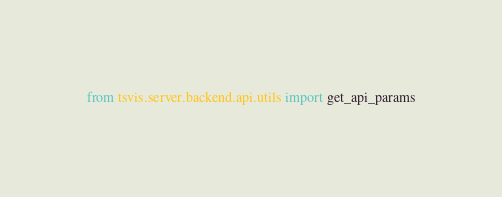Convert code to text. <code><loc_0><loc_0><loc_500><loc_500><_Python_>from tsvis.server.backend.api.utils import get_api_params</code> 